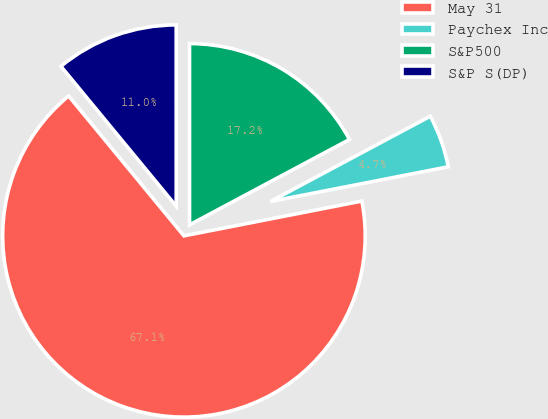<chart> <loc_0><loc_0><loc_500><loc_500><pie_chart><fcel>May 31<fcel>Paychex Inc<fcel>S&P500<fcel>S&P S(DP)<nl><fcel>67.1%<fcel>4.73%<fcel>17.2%<fcel>10.97%<nl></chart> 